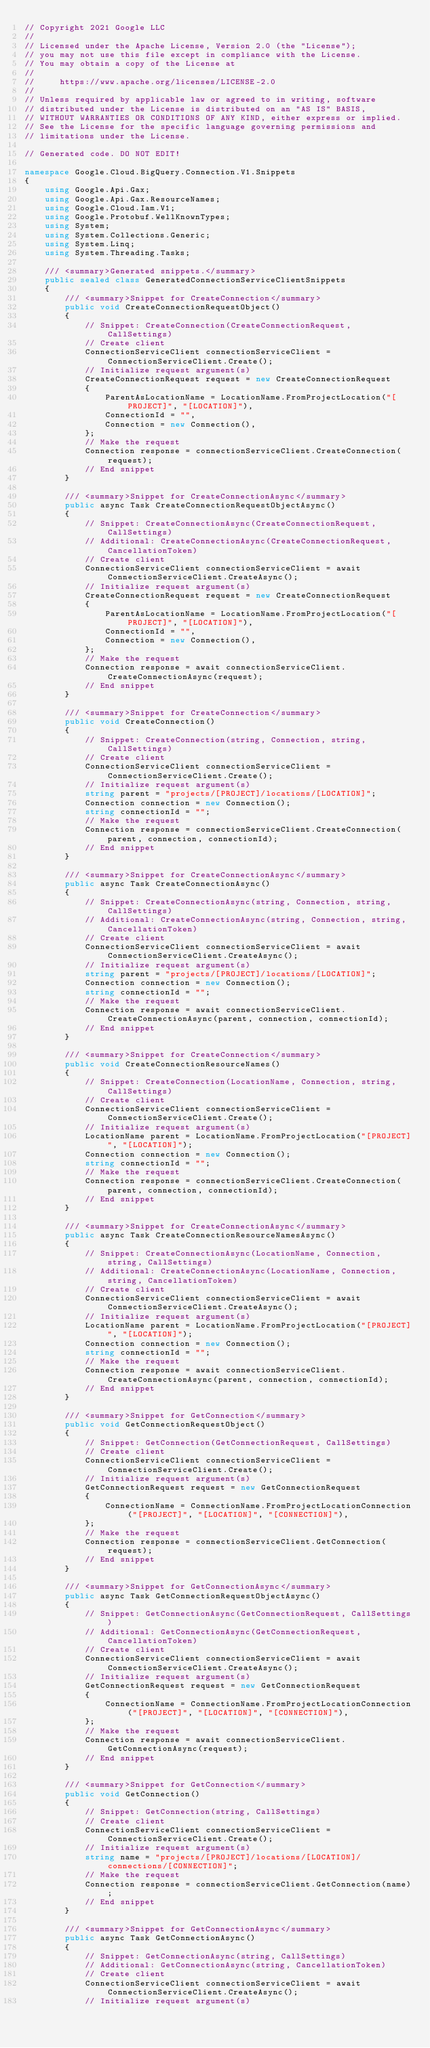Convert code to text. <code><loc_0><loc_0><loc_500><loc_500><_C#_>// Copyright 2021 Google LLC
//
// Licensed under the Apache License, Version 2.0 (the "License");
// you may not use this file except in compliance with the License.
// You may obtain a copy of the License at
//
//     https://www.apache.org/licenses/LICENSE-2.0
//
// Unless required by applicable law or agreed to in writing, software
// distributed under the License is distributed on an "AS IS" BASIS,
// WITHOUT WARRANTIES OR CONDITIONS OF ANY KIND, either express or implied.
// See the License for the specific language governing permissions and
// limitations under the License.

// Generated code. DO NOT EDIT!

namespace Google.Cloud.BigQuery.Connection.V1.Snippets
{
    using Google.Api.Gax;
    using Google.Api.Gax.ResourceNames;
    using Google.Cloud.Iam.V1;
    using Google.Protobuf.WellKnownTypes;
    using System;
    using System.Collections.Generic;
    using System.Linq;
    using System.Threading.Tasks;

    /// <summary>Generated snippets.</summary>
    public sealed class GeneratedConnectionServiceClientSnippets
    {
        /// <summary>Snippet for CreateConnection</summary>
        public void CreateConnectionRequestObject()
        {
            // Snippet: CreateConnection(CreateConnectionRequest, CallSettings)
            // Create client
            ConnectionServiceClient connectionServiceClient = ConnectionServiceClient.Create();
            // Initialize request argument(s)
            CreateConnectionRequest request = new CreateConnectionRequest
            {
                ParentAsLocationName = LocationName.FromProjectLocation("[PROJECT]", "[LOCATION]"),
                ConnectionId = "",
                Connection = new Connection(),
            };
            // Make the request
            Connection response = connectionServiceClient.CreateConnection(request);
            // End snippet
        }

        /// <summary>Snippet for CreateConnectionAsync</summary>
        public async Task CreateConnectionRequestObjectAsync()
        {
            // Snippet: CreateConnectionAsync(CreateConnectionRequest, CallSettings)
            // Additional: CreateConnectionAsync(CreateConnectionRequest, CancellationToken)
            // Create client
            ConnectionServiceClient connectionServiceClient = await ConnectionServiceClient.CreateAsync();
            // Initialize request argument(s)
            CreateConnectionRequest request = new CreateConnectionRequest
            {
                ParentAsLocationName = LocationName.FromProjectLocation("[PROJECT]", "[LOCATION]"),
                ConnectionId = "",
                Connection = new Connection(),
            };
            // Make the request
            Connection response = await connectionServiceClient.CreateConnectionAsync(request);
            // End snippet
        }

        /// <summary>Snippet for CreateConnection</summary>
        public void CreateConnection()
        {
            // Snippet: CreateConnection(string, Connection, string, CallSettings)
            // Create client
            ConnectionServiceClient connectionServiceClient = ConnectionServiceClient.Create();
            // Initialize request argument(s)
            string parent = "projects/[PROJECT]/locations/[LOCATION]";
            Connection connection = new Connection();
            string connectionId = "";
            // Make the request
            Connection response = connectionServiceClient.CreateConnection(parent, connection, connectionId);
            // End snippet
        }

        /// <summary>Snippet for CreateConnectionAsync</summary>
        public async Task CreateConnectionAsync()
        {
            // Snippet: CreateConnectionAsync(string, Connection, string, CallSettings)
            // Additional: CreateConnectionAsync(string, Connection, string, CancellationToken)
            // Create client
            ConnectionServiceClient connectionServiceClient = await ConnectionServiceClient.CreateAsync();
            // Initialize request argument(s)
            string parent = "projects/[PROJECT]/locations/[LOCATION]";
            Connection connection = new Connection();
            string connectionId = "";
            // Make the request
            Connection response = await connectionServiceClient.CreateConnectionAsync(parent, connection, connectionId);
            // End snippet
        }

        /// <summary>Snippet for CreateConnection</summary>
        public void CreateConnectionResourceNames()
        {
            // Snippet: CreateConnection(LocationName, Connection, string, CallSettings)
            // Create client
            ConnectionServiceClient connectionServiceClient = ConnectionServiceClient.Create();
            // Initialize request argument(s)
            LocationName parent = LocationName.FromProjectLocation("[PROJECT]", "[LOCATION]");
            Connection connection = new Connection();
            string connectionId = "";
            // Make the request
            Connection response = connectionServiceClient.CreateConnection(parent, connection, connectionId);
            // End snippet
        }

        /// <summary>Snippet for CreateConnectionAsync</summary>
        public async Task CreateConnectionResourceNamesAsync()
        {
            // Snippet: CreateConnectionAsync(LocationName, Connection, string, CallSettings)
            // Additional: CreateConnectionAsync(LocationName, Connection, string, CancellationToken)
            // Create client
            ConnectionServiceClient connectionServiceClient = await ConnectionServiceClient.CreateAsync();
            // Initialize request argument(s)
            LocationName parent = LocationName.FromProjectLocation("[PROJECT]", "[LOCATION]");
            Connection connection = new Connection();
            string connectionId = "";
            // Make the request
            Connection response = await connectionServiceClient.CreateConnectionAsync(parent, connection, connectionId);
            // End snippet
        }

        /// <summary>Snippet for GetConnection</summary>
        public void GetConnectionRequestObject()
        {
            // Snippet: GetConnection(GetConnectionRequest, CallSettings)
            // Create client
            ConnectionServiceClient connectionServiceClient = ConnectionServiceClient.Create();
            // Initialize request argument(s)
            GetConnectionRequest request = new GetConnectionRequest
            {
                ConnectionName = ConnectionName.FromProjectLocationConnection("[PROJECT]", "[LOCATION]", "[CONNECTION]"),
            };
            // Make the request
            Connection response = connectionServiceClient.GetConnection(request);
            // End snippet
        }

        /// <summary>Snippet for GetConnectionAsync</summary>
        public async Task GetConnectionRequestObjectAsync()
        {
            // Snippet: GetConnectionAsync(GetConnectionRequest, CallSettings)
            // Additional: GetConnectionAsync(GetConnectionRequest, CancellationToken)
            // Create client
            ConnectionServiceClient connectionServiceClient = await ConnectionServiceClient.CreateAsync();
            // Initialize request argument(s)
            GetConnectionRequest request = new GetConnectionRequest
            {
                ConnectionName = ConnectionName.FromProjectLocationConnection("[PROJECT]", "[LOCATION]", "[CONNECTION]"),
            };
            // Make the request
            Connection response = await connectionServiceClient.GetConnectionAsync(request);
            // End snippet
        }

        /// <summary>Snippet for GetConnection</summary>
        public void GetConnection()
        {
            // Snippet: GetConnection(string, CallSettings)
            // Create client
            ConnectionServiceClient connectionServiceClient = ConnectionServiceClient.Create();
            // Initialize request argument(s)
            string name = "projects/[PROJECT]/locations/[LOCATION]/connections/[CONNECTION]";
            // Make the request
            Connection response = connectionServiceClient.GetConnection(name);
            // End snippet
        }

        /// <summary>Snippet for GetConnectionAsync</summary>
        public async Task GetConnectionAsync()
        {
            // Snippet: GetConnectionAsync(string, CallSettings)
            // Additional: GetConnectionAsync(string, CancellationToken)
            // Create client
            ConnectionServiceClient connectionServiceClient = await ConnectionServiceClient.CreateAsync();
            // Initialize request argument(s)</code> 